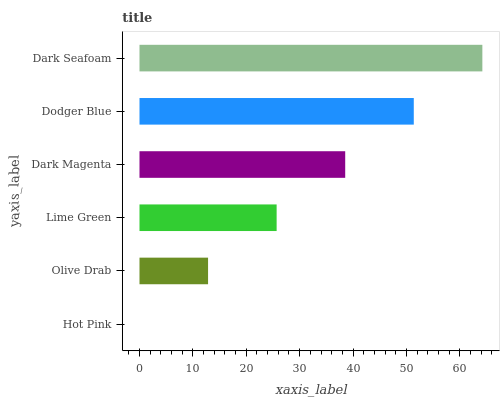Is Hot Pink the minimum?
Answer yes or no. Yes. Is Dark Seafoam the maximum?
Answer yes or no. Yes. Is Olive Drab the minimum?
Answer yes or no. No. Is Olive Drab the maximum?
Answer yes or no. No. Is Olive Drab greater than Hot Pink?
Answer yes or no. Yes. Is Hot Pink less than Olive Drab?
Answer yes or no. Yes. Is Hot Pink greater than Olive Drab?
Answer yes or no. No. Is Olive Drab less than Hot Pink?
Answer yes or no. No. Is Dark Magenta the high median?
Answer yes or no. Yes. Is Lime Green the low median?
Answer yes or no. Yes. Is Lime Green the high median?
Answer yes or no. No. Is Dodger Blue the low median?
Answer yes or no. No. 